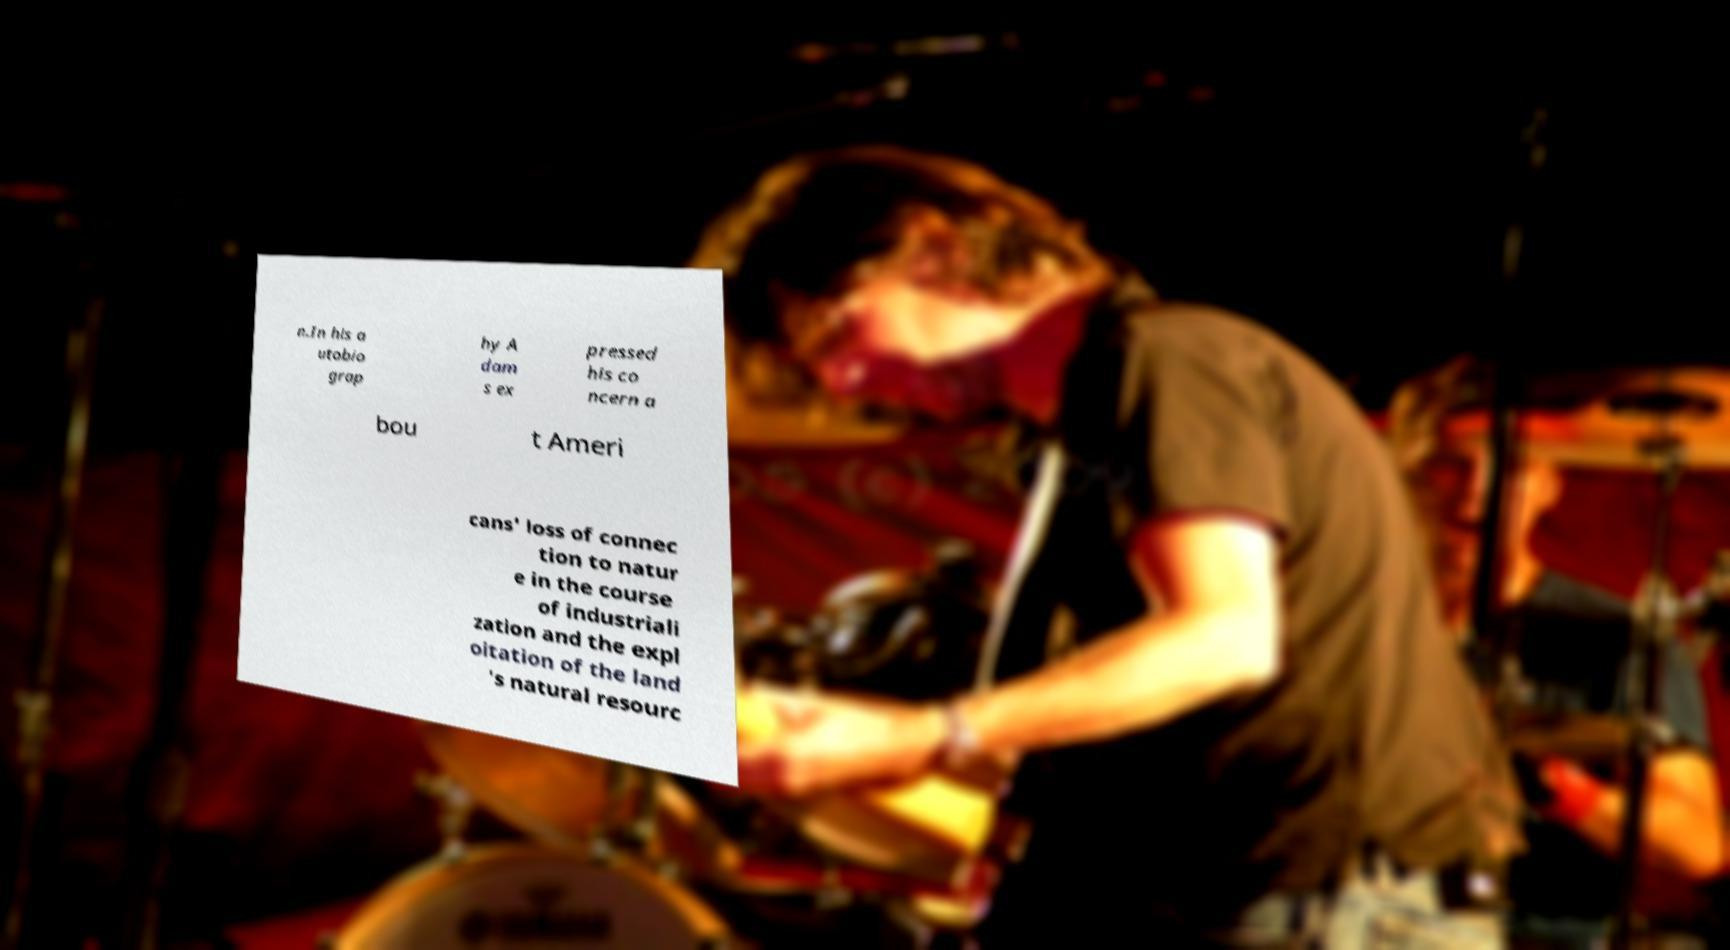What messages or text are displayed in this image? I need them in a readable, typed format. n.In his a utobio grap hy A dam s ex pressed his co ncern a bou t Ameri cans' loss of connec tion to natur e in the course of industriali zation and the expl oitation of the land 's natural resourc 